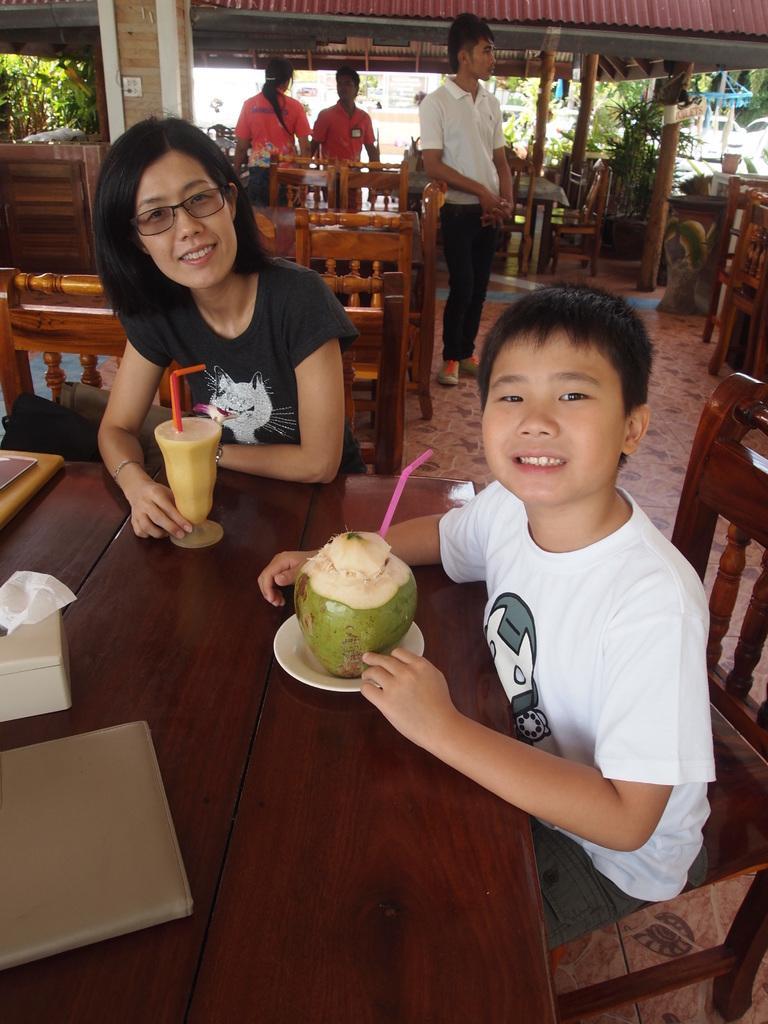In one or two sentences, can you explain what this image depicts? This picture is clicked in hotel or restaurant. Here, we see boy and women are sitting on chair in front of table. On table, we see file, tissue paper, coconut, plate and a glass containing juice are placed on it. Behind them, we see many chairs and tables and we even see three people standing in the hotel. On the left corner, we see trees and on top of the picture, we see the roof of that hotel. 